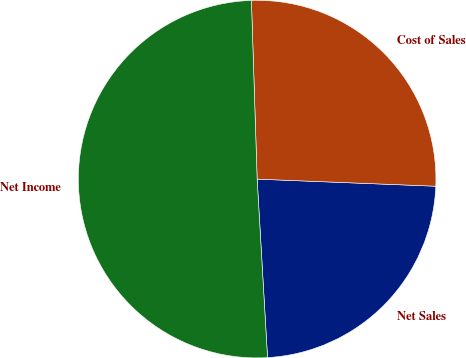Convert chart. <chart><loc_0><loc_0><loc_500><loc_500><pie_chart><fcel>Net Sales<fcel>Cost of Sales<fcel>Net Income<nl><fcel>23.44%<fcel>26.14%<fcel>50.41%<nl></chart> 